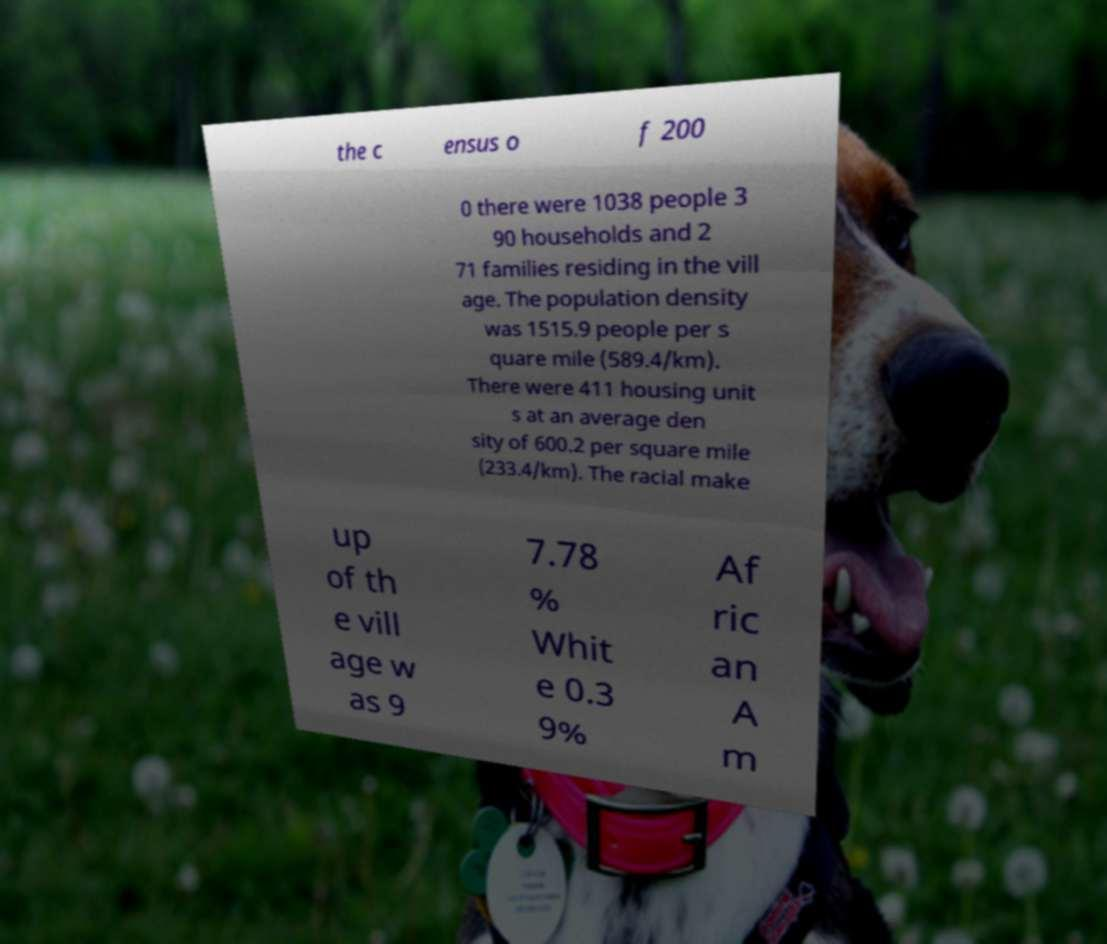Can you read and provide the text displayed in the image?This photo seems to have some interesting text. Can you extract and type it out for me? the c ensus o f 200 0 there were 1038 people 3 90 households and 2 71 families residing in the vill age. The population density was 1515.9 people per s quare mile (589.4/km). There were 411 housing unit s at an average den sity of 600.2 per square mile (233.4/km). The racial make up of th e vill age w as 9 7.78 % Whit e 0.3 9% Af ric an A m 